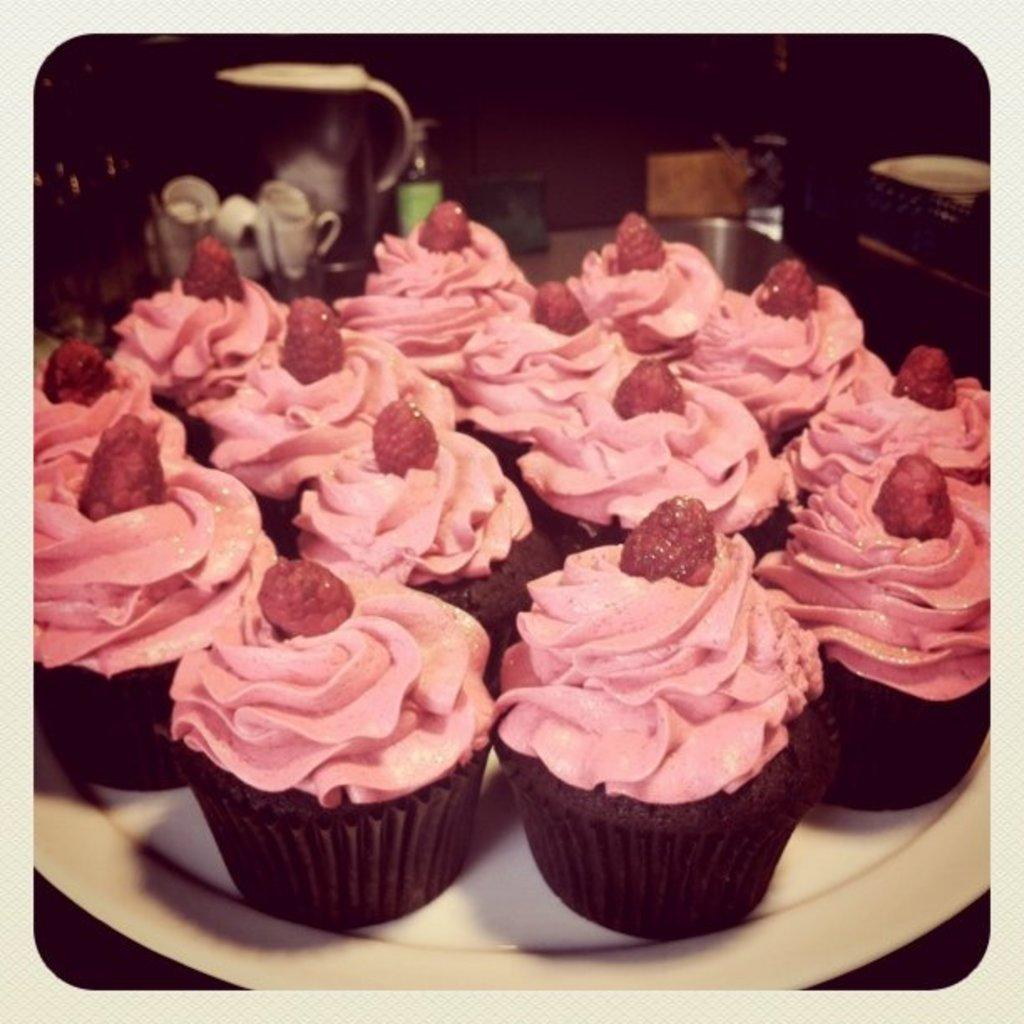What type of food is on the plate in the image? There are cupcakes on a plate in the image. Can you describe anything visible in the background of the image? Unfortunately, the provided facts do not give any information about the objects visible in the background of the image. What type of muscle is being exercised by the cupcakes in the image? Cupcakes do not have muscles, and they are not exercising any muscles in the image. 